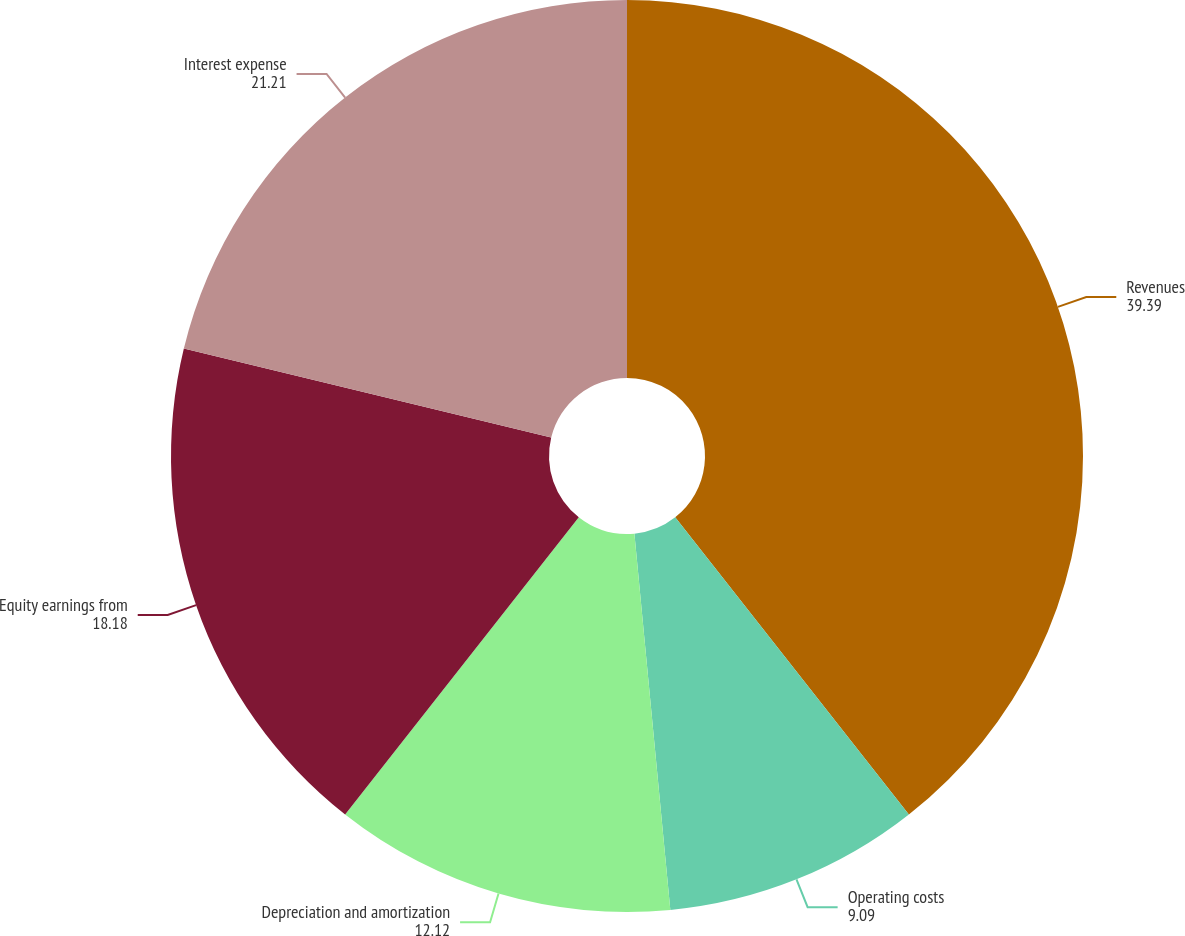Convert chart to OTSL. <chart><loc_0><loc_0><loc_500><loc_500><pie_chart><fcel>Revenues<fcel>Operating costs<fcel>Depreciation and amortization<fcel>Equity earnings from<fcel>Interest expense<nl><fcel>39.39%<fcel>9.09%<fcel>12.12%<fcel>18.18%<fcel>21.21%<nl></chart> 